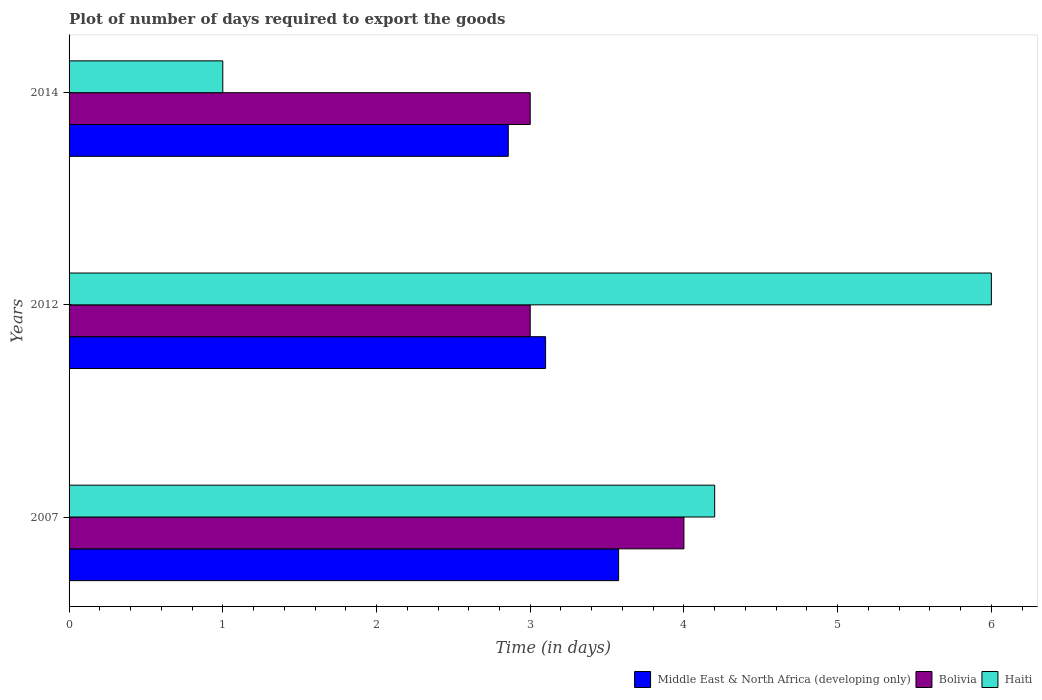How many different coloured bars are there?
Provide a short and direct response. 3. Are the number of bars on each tick of the Y-axis equal?
Make the answer very short. Yes. What is the label of the 2nd group of bars from the top?
Make the answer very short. 2012. In how many cases, is the number of bars for a given year not equal to the number of legend labels?
Your response must be concise. 0. Across all years, what is the maximum time required to export goods in Bolivia?
Keep it short and to the point. 4. Across all years, what is the minimum time required to export goods in Haiti?
Your answer should be compact. 1. In which year was the time required to export goods in Haiti maximum?
Provide a succinct answer. 2012. In which year was the time required to export goods in Haiti minimum?
Your response must be concise. 2014. What is the total time required to export goods in Bolivia in the graph?
Your answer should be very brief. 10. What is the difference between the time required to export goods in Middle East & North Africa (developing only) in 2007 and that in 2012?
Offer a terse response. 0.48. What is the difference between the time required to export goods in Bolivia in 2014 and the time required to export goods in Haiti in 2007?
Your answer should be very brief. -1.2. What is the average time required to export goods in Bolivia per year?
Ensure brevity in your answer.  3.33. In how many years, is the time required to export goods in Bolivia greater than 5.4 days?
Give a very brief answer. 0. What is the ratio of the time required to export goods in Bolivia in 2007 to that in 2014?
Offer a terse response. 1.33. Is the time required to export goods in Bolivia in 2007 less than that in 2014?
Offer a very short reply. No. What is the difference between the highest and the second highest time required to export goods in Middle East & North Africa (developing only)?
Ensure brevity in your answer.  0.48. What is the difference between the highest and the lowest time required to export goods in Haiti?
Keep it short and to the point. 5. In how many years, is the time required to export goods in Bolivia greater than the average time required to export goods in Bolivia taken over all years?
Your response must be concise. 1. Is the sum of the time required to export goods in Bolivia in 2012 and 2014 greater than the maximum time required to export goods in Middle East & North Africa (developing only) across all years?
Give a very brief answer. Yes. What does the 2nd bar from the top in 2014 represents?
Give a very brief answer. Bolivia. What does the 1st bar from the bottom in 2007 represents?
Provide a short and direct response. Middle East & North Africa (developing only). Is it the case that in every year, the sum of the time required to export goods in Middle East & North Africa (developing only) and time required to export goods in Bolivia is greater than the time required to export goods in Haiti?
Provide a succinct answer. Yes. Are all the bars in the graph horizontal?
Keep it short and to the point. Yes. How many years are there in the graph?
Offer a terse response. 3. Does the graph contain grids?
Offer a terse response. No. Where does the legend appear in the graph?
Your answer should be very brief. Bottom right. How many legend labels are there?
Offer a very short reply. 3. What is the title of the graph?
Your answer should be very brief. Plot of number of days required to export the goods. Does "Tunisia" appear as one of the legend labels in the graph?
Your response must be concise. No. What is the label or title of the X-axis?
Ensure brevity in your answer.  Time (in days). What is the label or title of the Y-axis?
Your answer should be very brief. Years. What is the Time (in days) in Middle East & North Africa (developing only) in 2007?
Ensure brevity in your answer.  3.58. What is the Time (in days) of Haiti in 2007?
Offer a very short reply. 4.2. What is the Time (in days) of Middle East & North Africa (developing only) in 2012?
Your response must be concise. 3.1. What is the Time (in days) of Middle East & North Africa (developing only) in 2014?
Provide a short and direct response. 2.86. Across all years, what is the maximum Time (in days) of Middle East & North Africa (developing only)?
Make the answer very short. 3.58. Across all years, what is the maximum Time (in days) in Bolivia?
Your answer should be compact. 4. Across all years, what is the maximum Time (in days) in Haiti?
Make the answer very short. 6. Across all years, what is the minimum Time (in days) of Middle East & North Africa (developing only)?
Provide a short and direct response. 2.86. Across all years, what is the minimum Time (in days) of Bolivia?
Ensure brevity in your answer.  3. What is the total Time (in days) in Middle East & North Africa (developing only) in the graph?
Offer a very short reply. 9.53. What is the total Time (in days) in Bolivia in the graph?
Provide a succinct answer. 10. What is the difference between the Time (in days) in Middle East & North Africa (developing only) in 2007 and that in 2012?
Make the answer very short. 0.47. What is the difference between the Time (in days) in Haiti in 2007 and that in 2012?
Your answer should be very brief. -1.8. What is the difference between the Time (in days) of Middle East & North Africa (developing only) in 2007 and that in 2014?
Make the answer very short. 0.72. What is the difference between the Time (in days) of Bolivia in 2007 and that in 2014?
Provide a succinct answer. 1. What is the difference between the Time (in days) in Haiti in 2007 and that in 2014?
Offer a very short reply. 3.2. What is the difference between the Time (in days) of Middle East & North Africa (developing only) in 2012 and that in 2014?
Provide a short and direct response. 0.24. What is the difference between the Time (in days) in Middle East & North Africa (developing only) in 2007 and the Time (in days) in Bolivia in 2012?
Provide a short and direct response. 0.57. What is the difference between the Time (in days) of Middle East & North Africa (developing only) in 2007 and the Time (in days) of Haiti in 2012?
Offer a very short reply. -2.42. What is the difference between the Time (in days) of Bolivia in 2007 and the Time (in days) of Haiti in 2012?
Offer a terse response. -2. What is the difference between the Time (in days) in Middle East & North Africa (developing only) in 2007 and the Time (in days) in Bolivia in 2014?
Your response must be concise. 0.57. What is the difference between the Time (in days) in Middle East & North Africa (developing only) in 2007 and the Time (in days) in Haiti in 2014?
Provide a succinct answer. 2.58. What is the difference between the Time (in days) in Middle East & North Africa (developing only) in 2012 and the Time (in days) in Haiti in 2014?
Offer a terse response. 2.1. What is the average Time (in days) in Middle East & North Africa (developing only) per year?
Make the answer very short. 3.18. What is the average Time (in days) of Haiti per year?
Give a very brief answer. 3.73. In the year 2007, what is the difference between the Time (in days) in Middle East & North Africa (developing only) and Time (in days) in Bolivia?
Offer a terse response. -0.42. In the year 2007, what is the difference between the Time (in days) of Middle East & North Africa (developing only) and Time (in days) of Haiti?
Your response must be concise. -0.62. In the year 2007, what is the difference between the Time (in days) in Bolivia and Time (in days) in Haiti?
Provide a short and direct response. -0.2. In the year 2012, what is the difference between the Time (in days) in Middle East & North Africa (developing only) and Time (in days) in Bolivia?
Keep it short and to the point. 0.1. In the year 2012, what is the difference between the Time (in days) in Bolivia and Time (in days) in Haiti?
Your answer should be very brief. -3. In the year 2014, what is the difference between the Time (in days) of Middle East & North Africa (developing only) and Time (in days) of Bolivia?
Keep it short and to the point. -0.14. In the year 2014, what is the difference between the Time (in days) of Middle East & North Africa (developing only) and Time (in days) of Haiti?
Your response must be concise. 1.86. In the year 2014, what is the difference between the Time (in days) of Bolivia and Time (in days) of Haiti?
Offer a very short reply. 2. What is the ratio of the Time (in days) of Middle East & North Africa (developing only) in 2007 to that in 2012?
Ensure brevity in your answer.  1.15. What is the ratio of the Time (in days) in Middle East & North Africa (developing only) in 2007 to that in 2014?
Your response must be concise. 1.25. What is the ratio of the Time (in days) in Haiti in 2007 to that in 2014?
Keep it short and to the point. 4.2. What is the ratio of the Time (in days) in Middle East & North Africa (developing only) in 2012 to that in 2014?
Ensure brevity in your answer.  1.08. What is the ratio of the Time (in days) of Bolivia in 2012 to that in 2014?
Make the answer very short. 1. What is the ratio of the Time (in days) of Haiti in 2012 to that in 2014?
Make the answer very short. 6. What is the difference between the highest and the second highest Time (in days) in Middle East & North Africa (developing only)?
Your response must be concise. 0.47. What is the difference between the highest and the second highest Time (in days) of Haiti?
Offer a very short reply. 1.8. What is the difference between the highest and the lowest Time (in days) of Middle East & North Africa (developing only)?
Your response must be concise. 0.72. What is the difference between the highest and the lowest Time (in days) in Bolivia?
Your answer should be very brief. 1. 